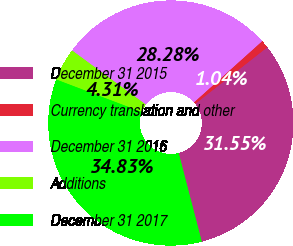<chart> <loc_0><loc_0><loc_500><loc_500><pie_chart><fcel>December 31 2015<fcel>Currency translation and other<fcel>December 31 2016<fcel>Additions<fcel>December 31 2017<nl><fcel>31.55%<fcel>1.04%<fcel>28.28%<fcel>4.31%<fcel>34.83%<nl></chart> 